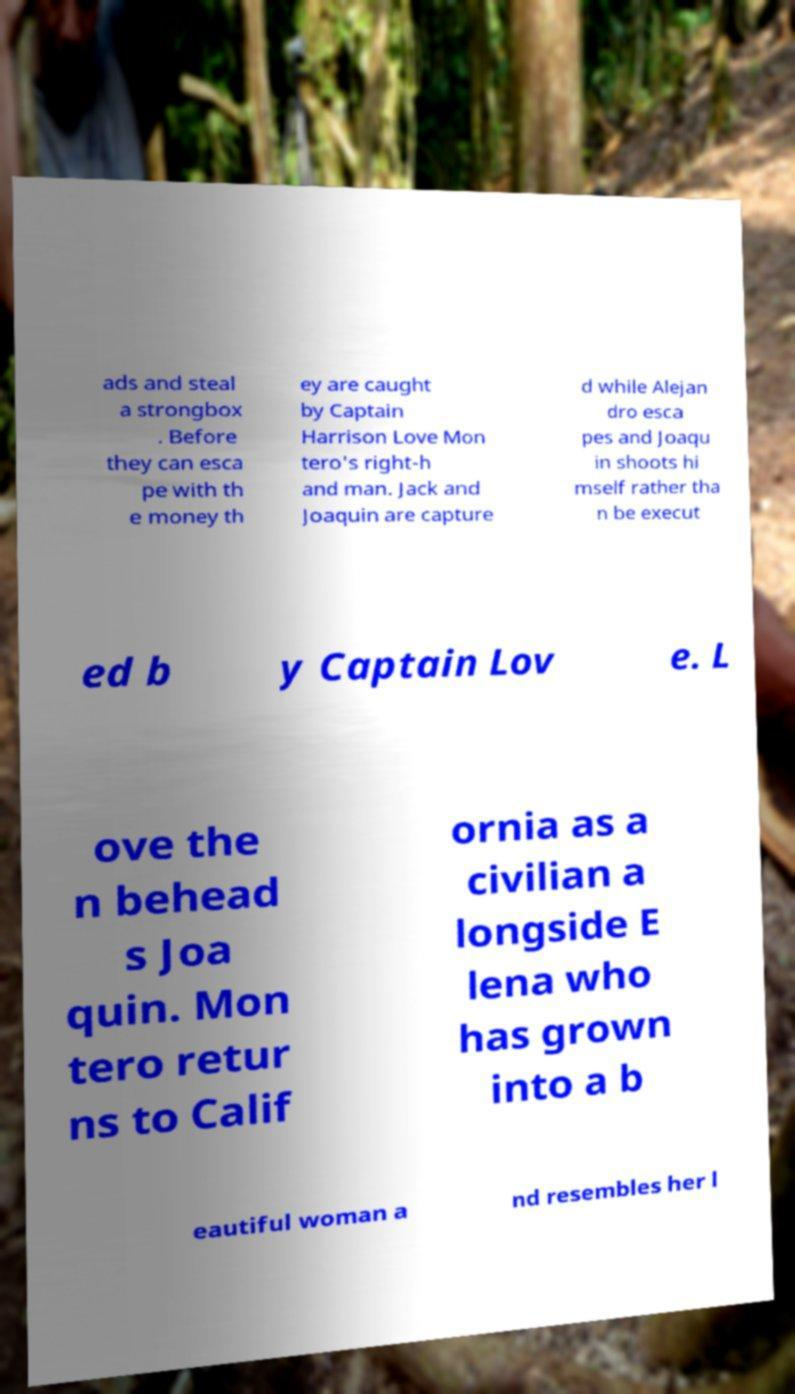There's text embedded in this image that I need extracted. Can you transcribe it verbatim? ads and steal a strongbox . Before they can esca pe with th e money th ey are caught by Captain Harrison Love Mon tero's right-h and man. Jack and Joaquin are capture d while Alejan dro esca pes and Joaqu in shoots hi mself rather tha n be execut ed b y Captain Lov e. L ove the n behead s Joa quin. Mon tero retur ns to Calif ornia as a civilian a longside E lena who has grown into a b eautiful woman a nd resembles her l 